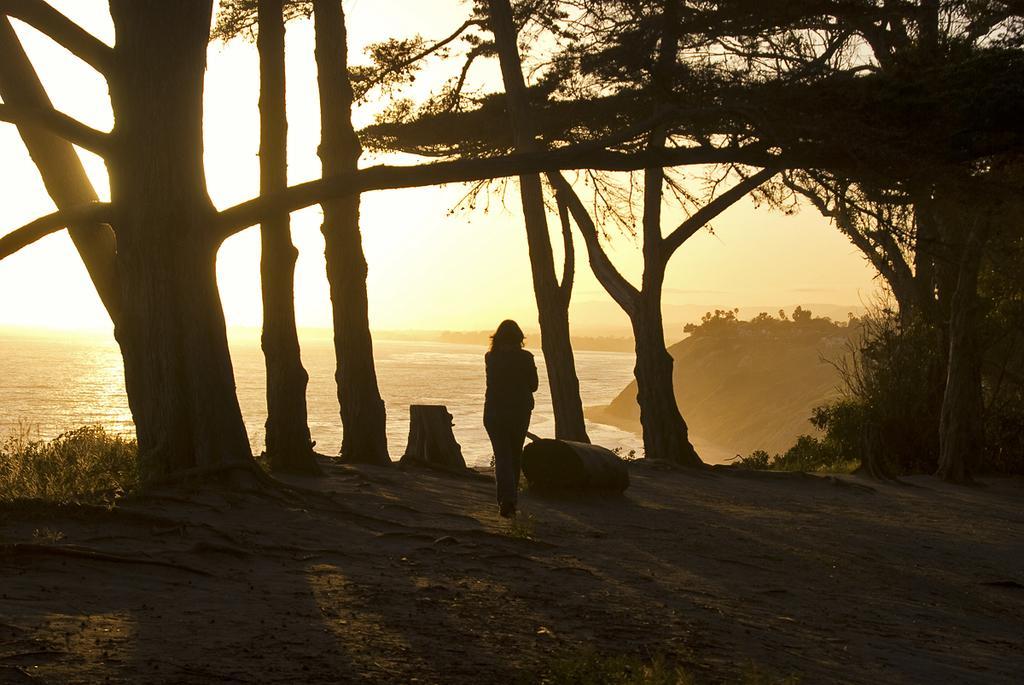In one or two sentences, can you explain what this image depicts? In this image we can see a person standing and looking at something, also we can see some trees and in the middle we can see the water, the background is the sky. 